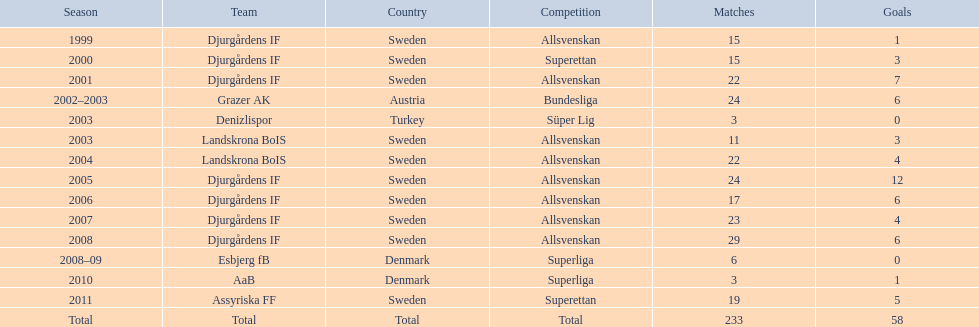Which season witnesses the highest number of goals? 2005. 